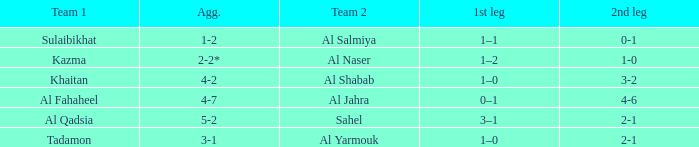What is the 1st leg of the Al Fahaheel Team 1? 0–1. 